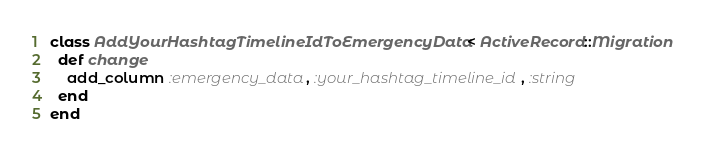Convert code to text. <code><loc_0><loc_0><loc_500><loc_500><_Ruby_>class AddYourHashtagTimelineIdToEmergencyData < ActiveRecord::Migration
  def change
    add_column :emergency_data, :your_hashtag_timeline_id, :string
  end
end
</code> 